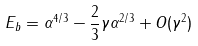Convert formula to latex. <formula><loc_0><loc_0><loc_500><loc_500>E _ { b } = \alpha ^ { 4 / 3 } - \frac { 2 } { 3 } \gamma \alpha ^ { 2 / 3 } + O ( \gamma ^ { 2 } )</formula> 